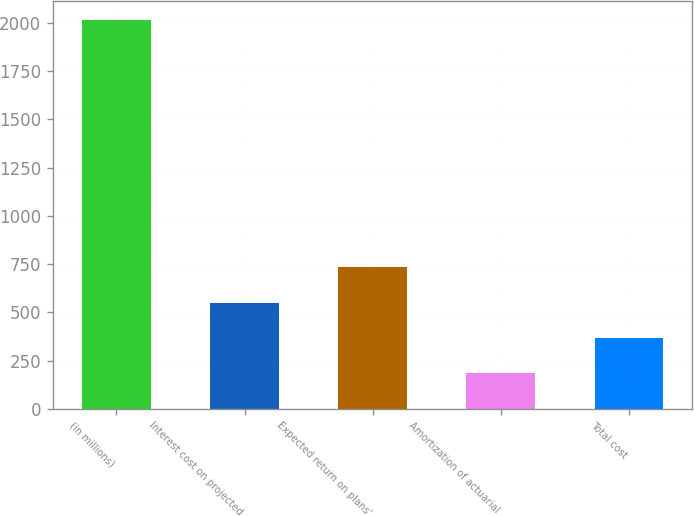<chart> <loc_0><loc_0><loc_500><loc_500><bar_chart><fcel>(in millions)<fcel>Interest cost on projected<fcel>Expected return on plans'<fcel>Amortization of actuarial<fcel>Total cost<nl><fcel>2015<fcel>550.2<fcel>733.3<fcel>184<fcel>367.1<nl></chart> 